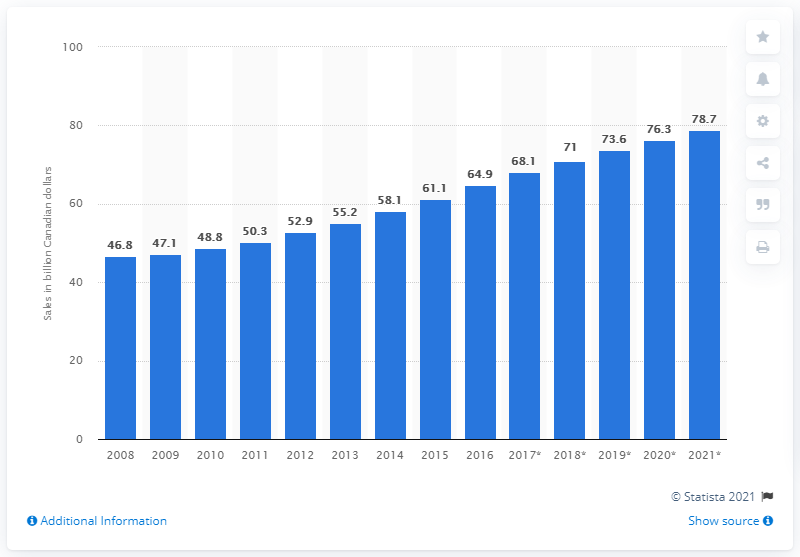List a handful of essential elements in this visual. The sales of foodservices in Canada in 2016 were 64.9 billion Canadian dollars. In 2018, the projected increase in sales of foodservices in Canada was 71%. 